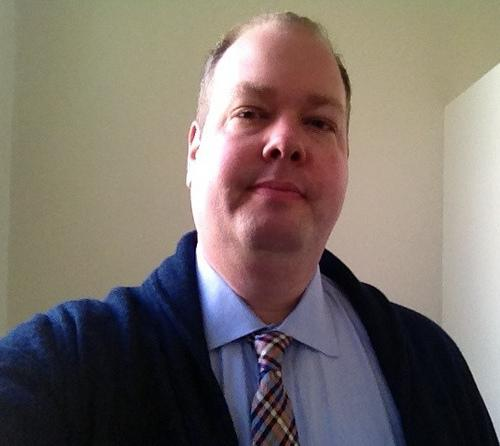Question: who is wearing a necktie?
Choices:
A. A groom.
B. A businessman.
C. A man.
D. A boy.
Answer with the letter. Answer: C Question: why the man is wearing necktie?
Choices:
A. He is at work.
B. He is going to a meeting.
C. He has an interview.
D. He is going to a wedding.
Answer with the letter. Answer: A Question: what is the color of the wall?
Choices:
A. Green.
B. Blue.
C. Almond.
D. White.
Answer with the letter. Answer: D 